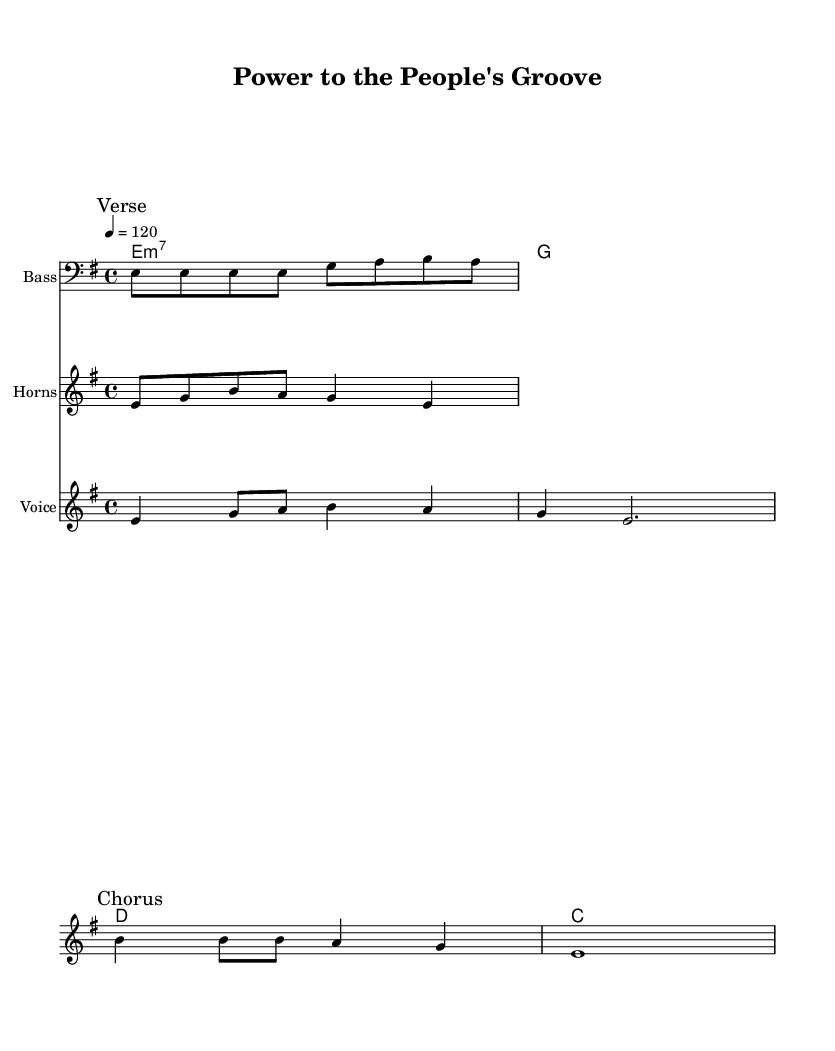What is the key signature of this music? The key signature is E minor, which is indicated by one sharp (F#) in this composition. This can be confirmed by looking at the key indicator at the beginning of the score.
Answer: E minor What is the time signature of this music? The time signature is 4/4, shown at the beginning of the score. This indicates that there are four beats in each measure and the quarter note gets one beat.
Answer: 4/4 What is the tempo marking for this music? The tempo marking is 120 beats per minute, indicated by the tempo command at the beginning of the piece. This tells the performer to play at a steady pace.
Answer: 120 How many measures are in the verse section? The verse section contains 2 measures, which can be counted by examining the segment marked "Verse" in the vocal melody. Each measure is clearly delineated by the bar lines.
Answer: 2 What is the primary theme of the lyrics? The primary theme of the lyrics expresses social yearning and empowerment, as suggested by lines that focus on communal struggles and aspirations. This reflects the political undercurrents typical of 70s funk music.
Answer: Social inequality What instrument is indicated for the horn riff? The instrument indicated for the horn riff is "Horns," as stated in the staff heading. This indicates that the musical line is intended for brass or woodwind instruments that can play this melody.
Answer: Horns What type of chords are used in the chord progression? The chord progression includes a minor seventh chord (E minor 7) followed by a major chord (G), and two major chords (D and C), which are characteristic of funk music due to their rich harmonic textures and ability to create groove.
Answer: Minor seventh and major chords 